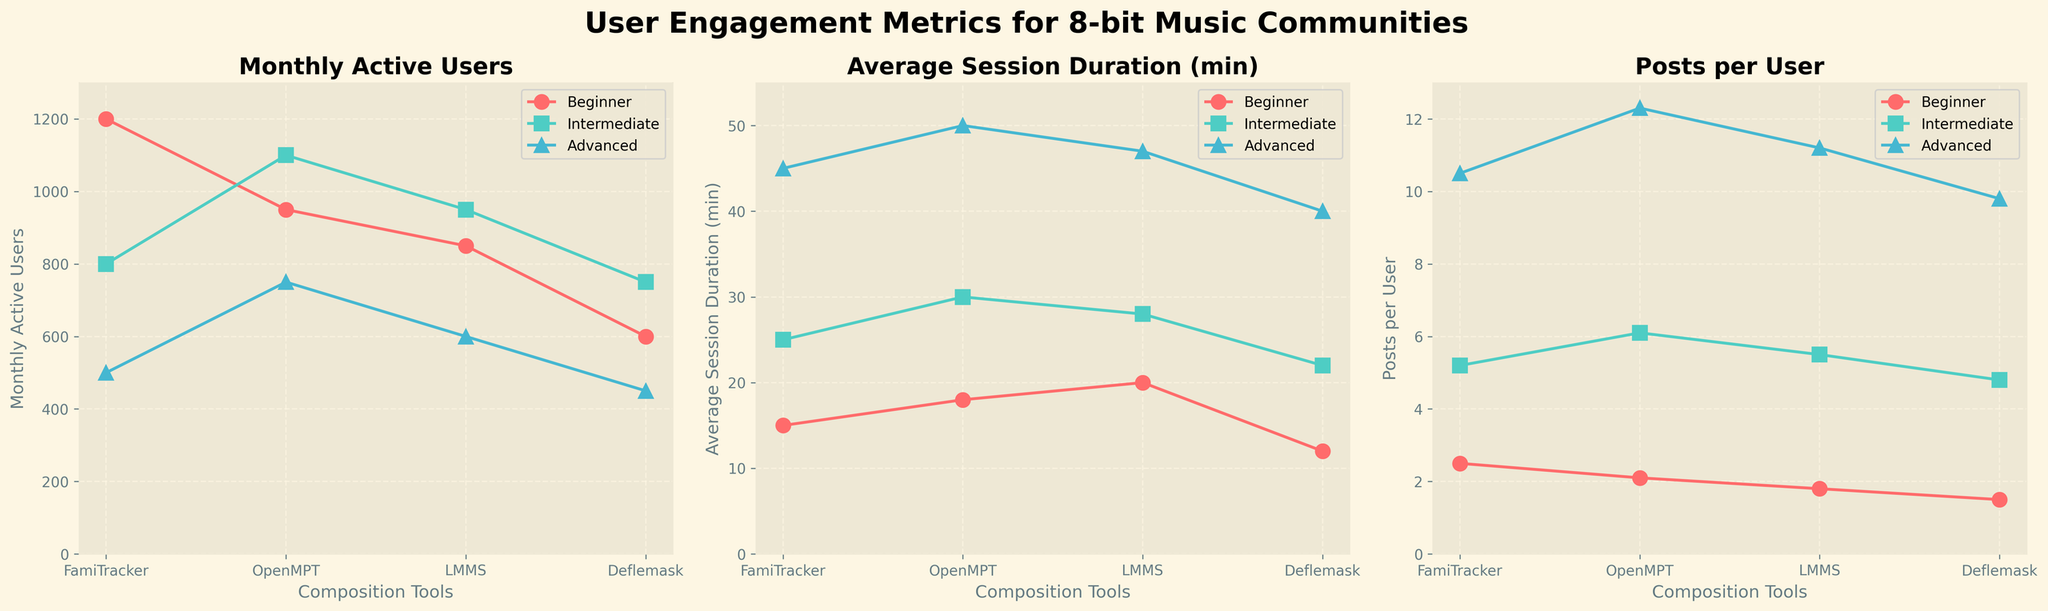What's the title of the figure? The title is usually placed at the top of the figure and summarizes what the figure is about. This figure has the title "User Engagement Metrics for 8-bit Music Communities".
Answer: User Engagement Metrics for 8-bit Music Communities What is the Y-axis label for the third subplot? The Y-axis label is the title of the Y-axis, which usually describes what is being measured. In the third subplot, it specifies "Posts per User".
Answer: Posts per User Which user experience level has the highest "Average Session Duration (min)" for OpenMPT? To find this, look at the data points for the "Average Session Duration (min)" metric in the second subplot. Compare the values associated with OpenMPT for each experience level. The highest value is for Advanced users.
Answer: Advanced How many metrics are being compared in the subplots? Count the number of different metrics being displayed in each subplot. There are three metrics divided into three subplots: "Monthly Active Users", "Average Session Duration (min)", and "Posts per User".
Answer: 3 For the metric "Monthly Active Users", which composition tool has the highest value for Beginners? Look at the first subplot and find the "Monthly Active Users" values for Beginners for each composition tool. The highest value for Beginners is FamiTracker.
Answer: FamiTracker What is the difference in "Average Session Duration (min)" between Intermediate and Advanced users for LMMS? In the second subplot, find the "Average Session Duration (min)" values for LMMS for Intermediate and Advanced users. Subtract the Intermediate value (28) from the Advanced value (47).
Answer: 19 Which composition tool has the lowest "Posts per User" for Intermediate users? Look at the third subplot and find the values for "Posts per User" for Intermediate users for each composition tool. The lowest value for Intermediate users is Deflemask.
Answer: Deflemask What are the colors used to represent different user experience levels in the figure? The colors assigned to the lines for each user experience level in the subplots were consistent: red for Beginner, teal for Intermediate, and blue for Advanced. Identify these colors across the subplots.
Answer: Red (Beginner), Teal (Intermediate), Blue (Advanced) Which user experience group spends the most average time per session on Deflemask? In the second subplot, identify the "Average Session Duration (min)" values for Deflemask for each user experience level. The Advanced group spends the most time.
Answer: Advanced 